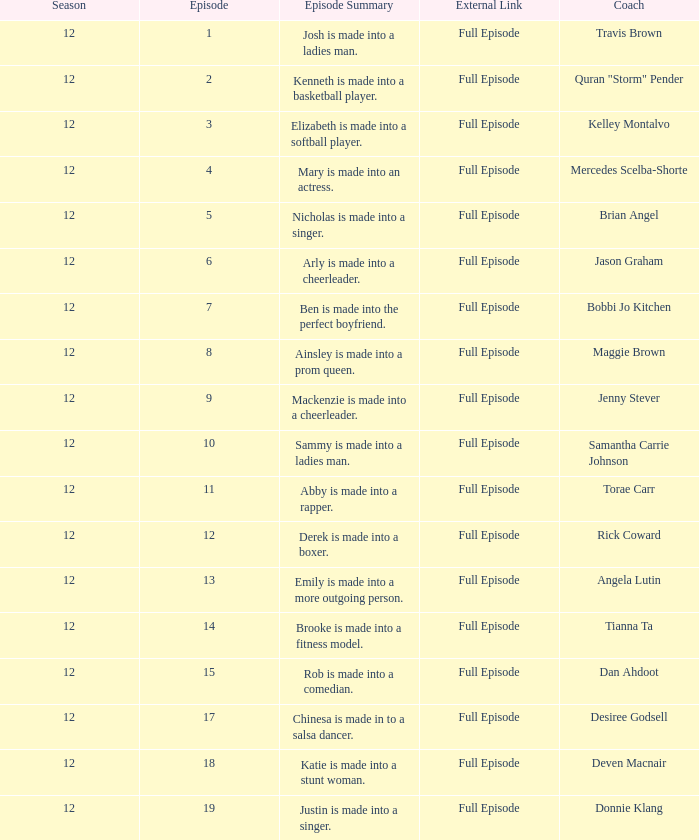Name the least episode for donnie klang 19.0. 